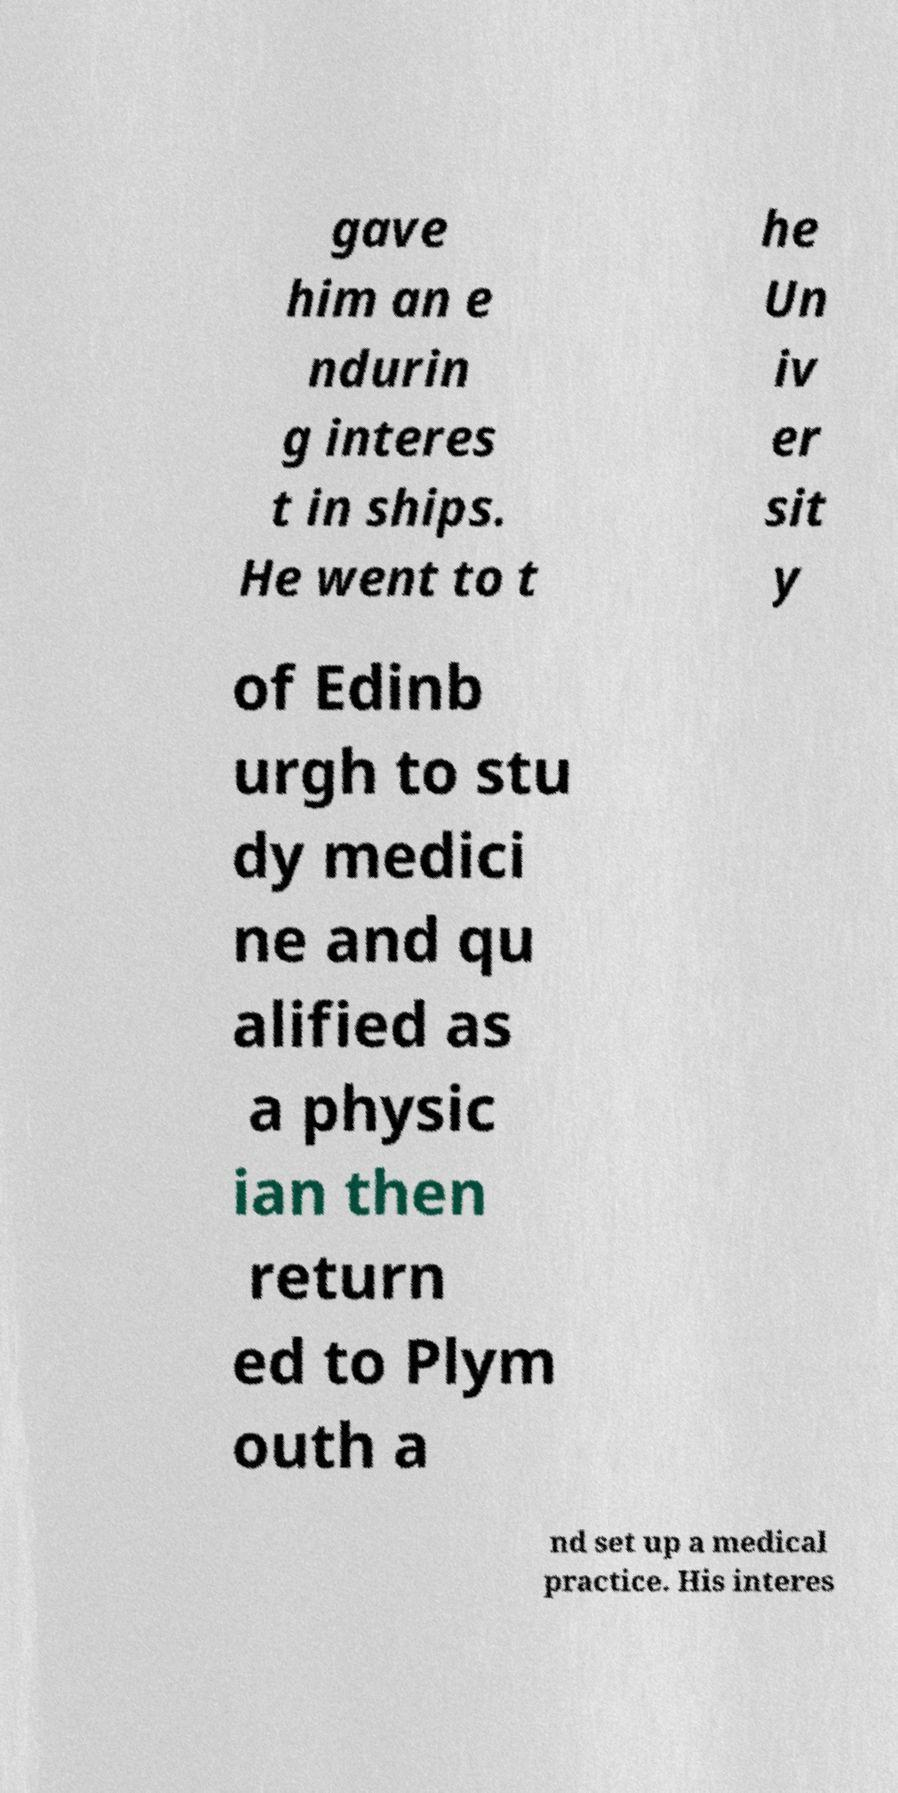Please read and relay the text visible in this image. What does it say? gave him an e ndurin g interes t in ships. He went to t he Un iv er sit y of Edinb urgh to stu dy medici ne and qu alified as a physic ian then return ed to Plym outh a nd set up a medical practice. His interes 